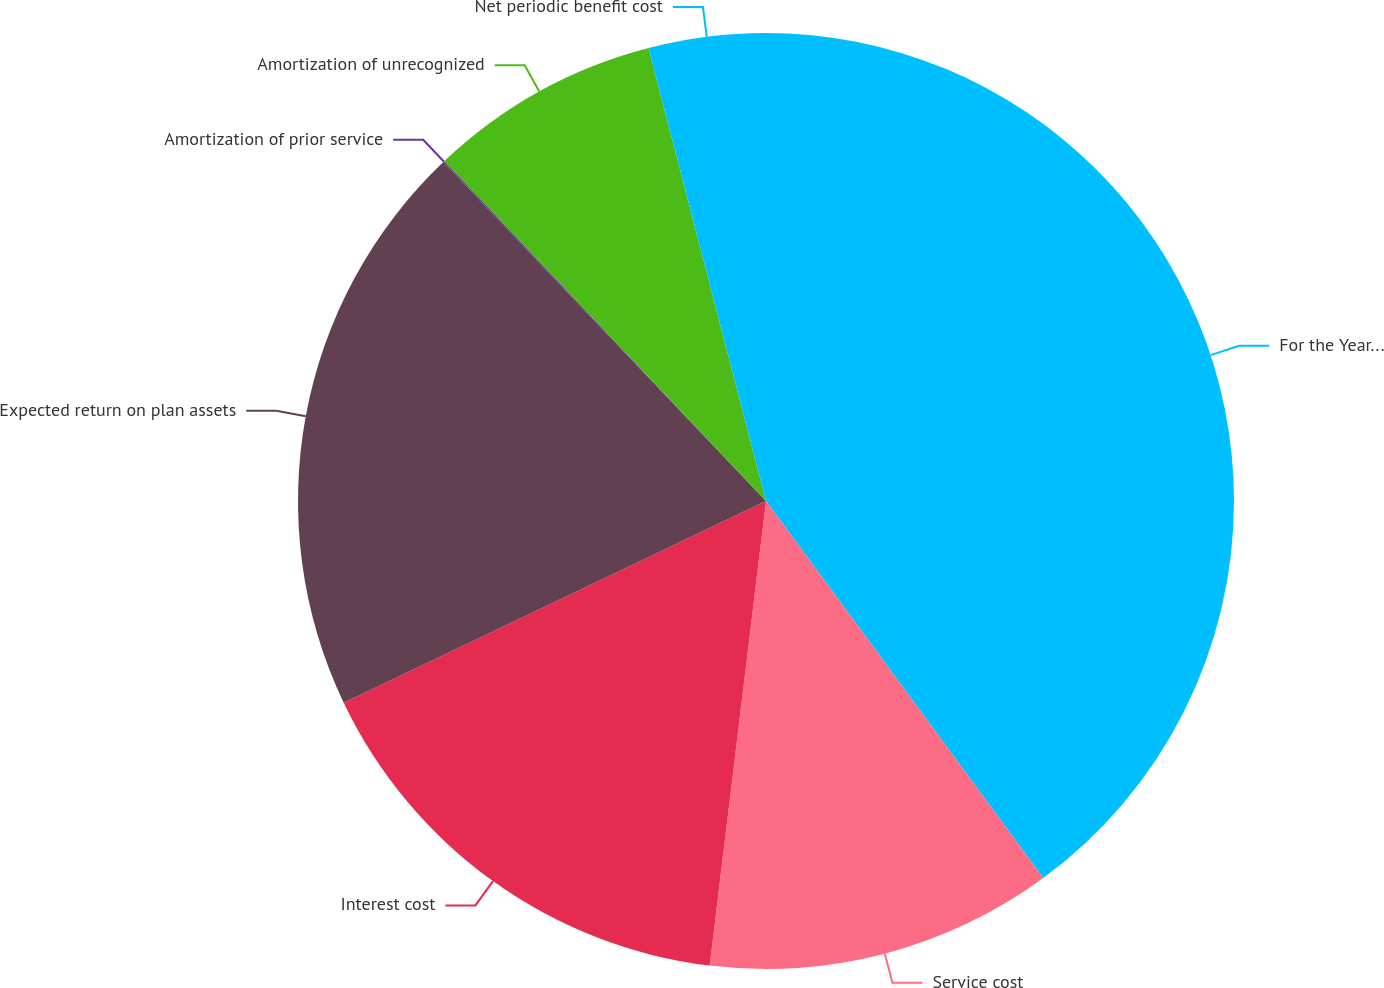Convert chart to OTSL. <chart><loc_0><loc_0><loc_500><loc_500><pie_chart><fcel>For the Years Ended December<fcel>Service cost<fcel>Interest cost<fcel>Expected return on plan assets<fcel>Amortization of prior service<fcel>Amortization of unrecognized<fcel>Net periodic benefit cost<nl><fcel>39.91%<fcel>12.01%<fcel>15.99%<fcel>19.98%<fcel>0.05%<fcel>8.02%<fcel>4.04%<nl></chart> 